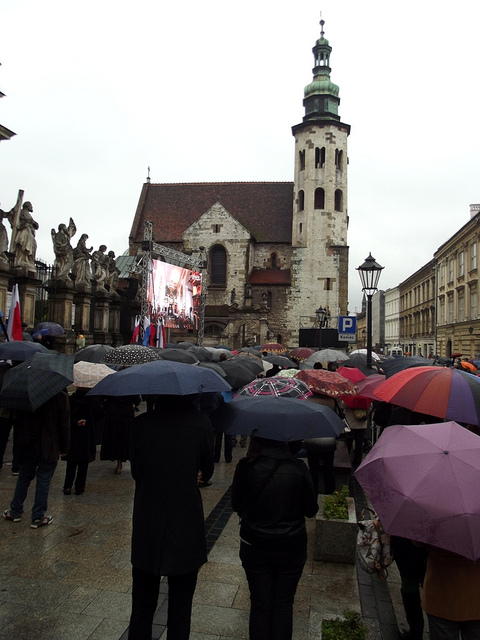<image>What color are the tables? There are no tables in the image. However, the color can be brown or gray. What is the name of the large monument in this picture? I don't know the name of the large monument in this picture. It could be Big Ben, a Spire, a Tower, or the Berlin Tower. What flag is in the photo? There is no flag in the photo. But it might be of France, Swiss, Prague or US. What color are the tables? There are no tables in the image. What flag is in the photo? There is no flag in the photo. What is the name of the large monument in this picture? I don't know the name of the large monument in this picture. It can be Big Ben, spire, tower, Berlin Tower or peso. 